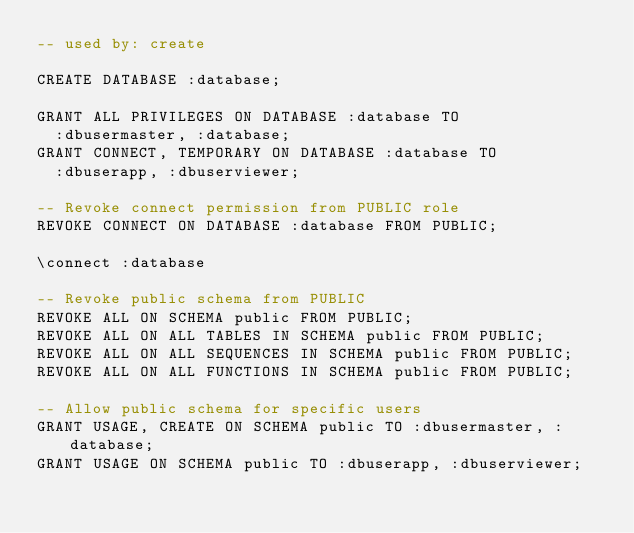Convert code to text. <code><loc_0><loc_0><loc_500><loc_500><_SQL_>-- used by: create

CREATE DATABASE :database;

GRANT ALL PRIVILEGES ON DATABASE :database TO
  :dbusermaster, :database;
GRANT CONNECT, TEMPORARY ON DATABASE :database TO
  :dbuserapp, :dbuserviewer;

-- Revoke connect permission from PUBLIC role
REVOKE CONNECT ON DATABASE :database FROM PUBLIC;

\connect :database

-- Revoke public schema from PUBLIC
REVOKE ALL ON SCHEMA public FROM PUBLIC;
REVOKE ALL ON ALL TABLES IN SCHEMA public FROM PUBLIC;
REVOKE ALL ON ALL SEQUENCES IN SCHEMA public FROM PUBLIC;
REVOKE ALL ON ALL FUNCTIONS IN SCHEMA public FROM PUBLIC;

-- Allow public schema for specific users
GRANT USAGE, CREATE ON SCHEMA public TO :dbusermaster, :database;
GRANT USAGE ON SCHEMA public TO :dbuserapp, :dbuserviewer;
</code> 